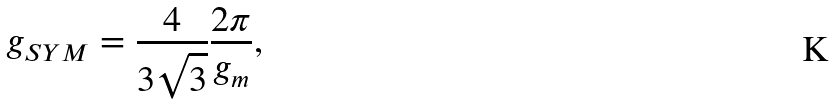<formula> <loc_0><loc_0><loc_500><loc_500>g _ { S Y M } = \frac { 4 } { 3 \sqrt { 3 } } \frac { 2 \pi } { g _ { m } } ,</formula> 